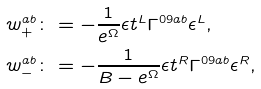<formula> <loc_0><loc_0><loc_500><loc_500>& w _ { + } ^ { a b } \colon = - \frac { 1 } { e ^ { \Omega } } \epsilon t ^ { L } \Gamma ^ { 0 9 a b } \epsilon ^ { L } , \\ & w _ { - } ^ { a b } \colon = - \frac { 1 } { B - e ^ { \Omega } } \epsilon t ^ { R } \Gamma ^ { 0 9 a b } \epsilon ^ { R } ,</formula> 